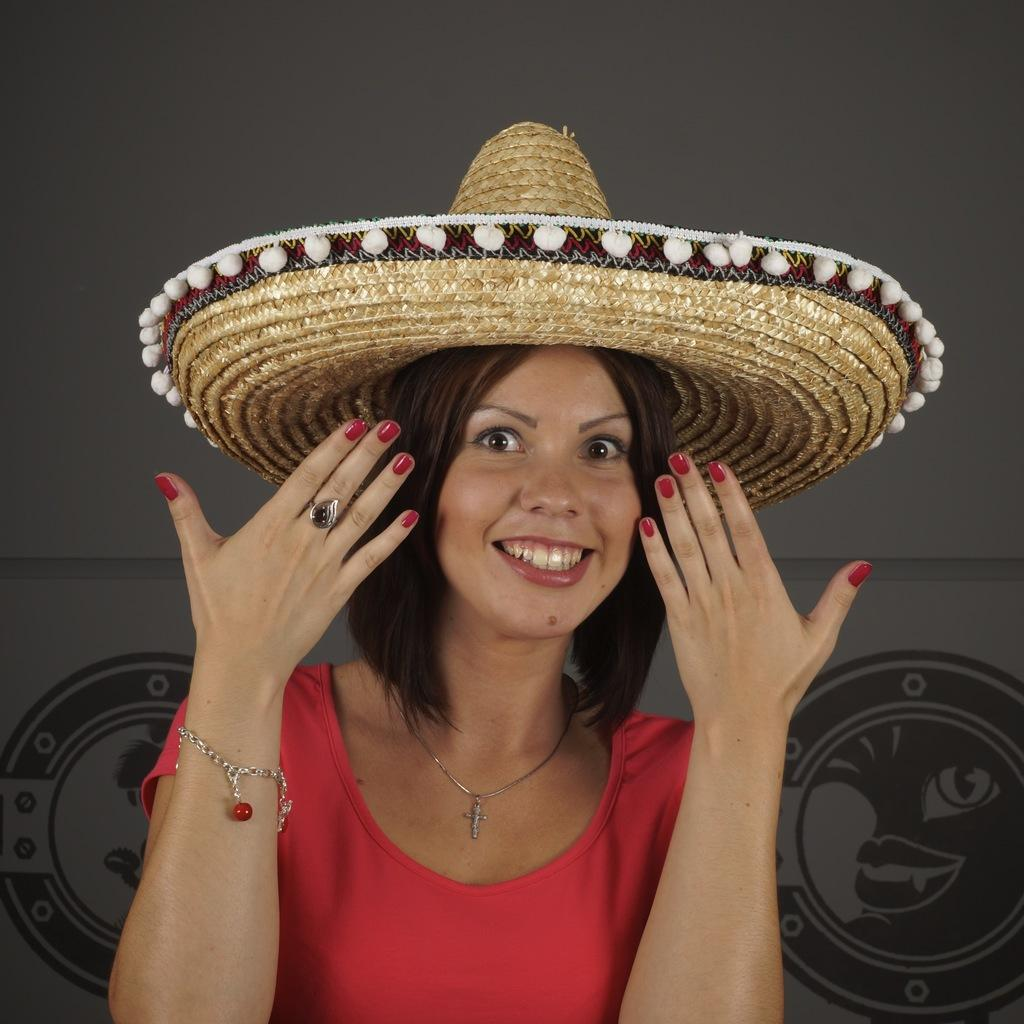Who is the main subject in the image? There is a lady in the image. What is the lady wearing on her head? The lady is wearing a hat. What type of toothbrush is the scarecrow holding in the image? There is no scarecrow or toothbrush present in the image; it features a lady wearing a hat. 